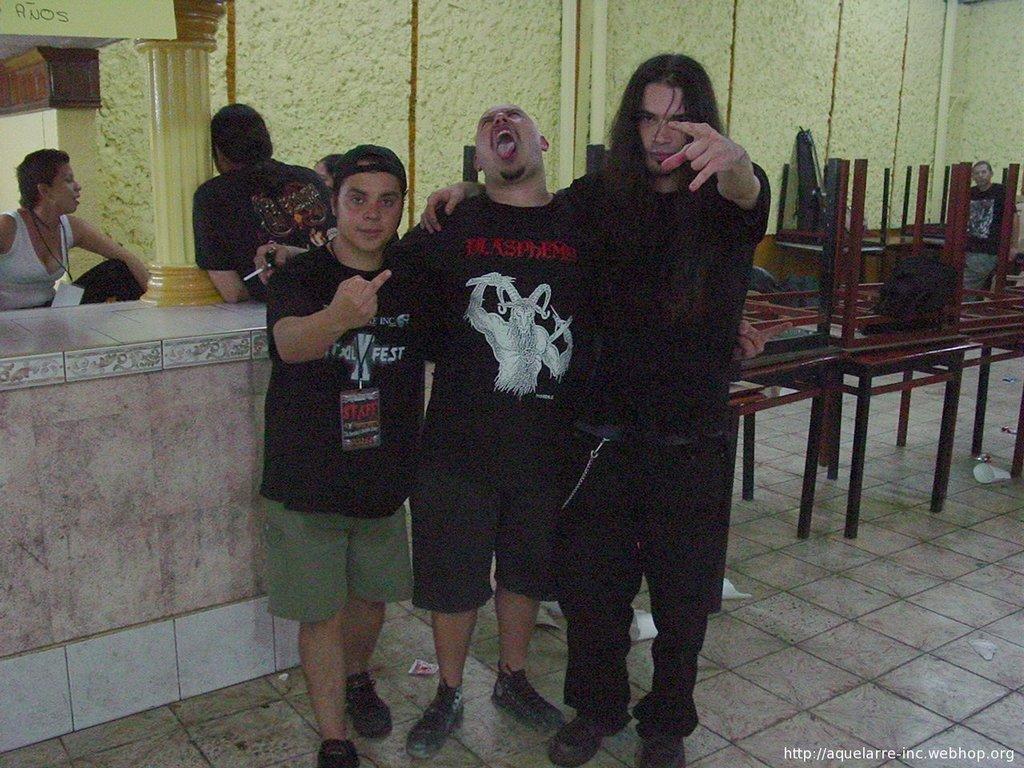In one or two sentences, can you explain what this image depicts? This picture shows a room and we see few people standing and we see tables and a bag on it and we see a man wear a cap on his head and on the side we see a woman seated and she wore a id card and we see a man holding a cigarette in his hand. 